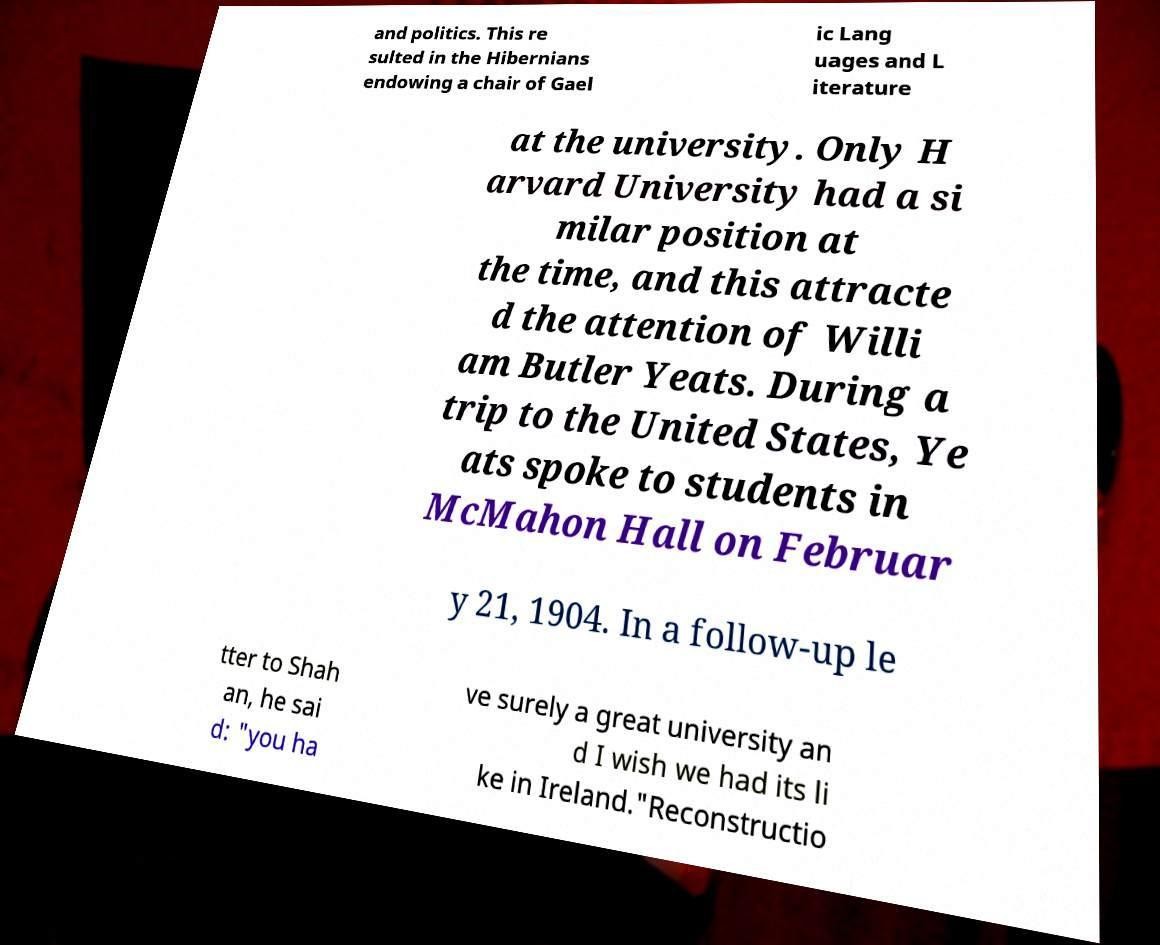Please identify and transcribe the text found in this image. and politics. This re sulted in the Hibernians endowing a chair of Gael ic Lang uages and L iterature at the university. Only H arvard University had a si milar position at the time, and this attracte d the attention of Willi am Butler Yeats. During a trip to the United States, Ye ats spoke to students in McMahon Hall on Februar y 21, 1904. In a follow-up le tter to Shah an, he sai d: "you ha ve surely a great university an d I wish we had its li ke in Ireland."Reconstructio 